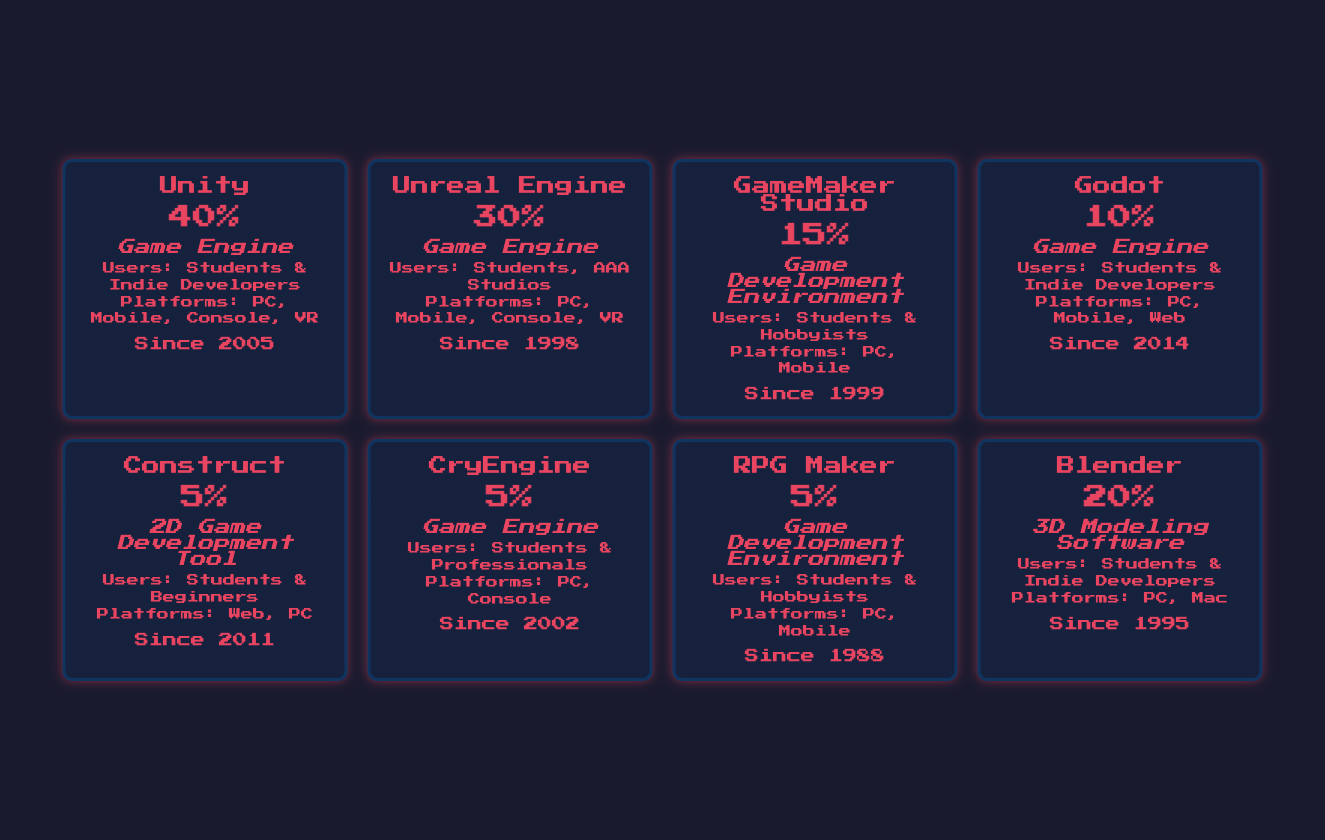What is the most popular game development software among students? The table lists the popularity percentages for each software. Unity has the highest popularity at 40%.
Answer: Unity Which game development software was introduced first? The table provides the year introduced for each software. The earliest year is 1988 for RPG Maker.
Answer: RPG Maker What percentage of students use Unreal Engine? According to the table, Unreal Engine has a popularity of 30%.
Answer: 30% Is there any game development software that supports mobile platforms and is used by hobbyists? The table indicates that GameMaker Studio is used by students and hobbyists, and it supports mobile platforms.
Answer: Yes Calculate the average popularity percentage of all the game development software listed. The popularity values are 40, 30, 15, 10, 5, 5, 5, and 20. Summing these gives 130. There are 8 software, so the average is 130/8 = 16.25.
Answer: 16.25 What percentage of software listed is used by students and indie developers? Referring to the table, Unity, Godot, and Blender are mentioned as used by students and indie developers. Their popularity percentages are 40, 10, and 20, respectively. The sum is 70%.
Answer: 70% Which software has the lowest popularity and what is that percentage? The table shows that both Construct, CryEngine, and RPG Maker have the lowest popularity at 5%.
Answer: 5% Do more students use GameMaker Studio than Godot? GameMaker Studio has a popularity of 15%, while Godot has 10%. Therefore, more students use GameMaker Studio than Godot.
Answer: Yes Which game development software is specifically categorized as a 2D Game Development Tool? The table identifies Construct as a 2D Game Development Tool.
Answer: Construct 